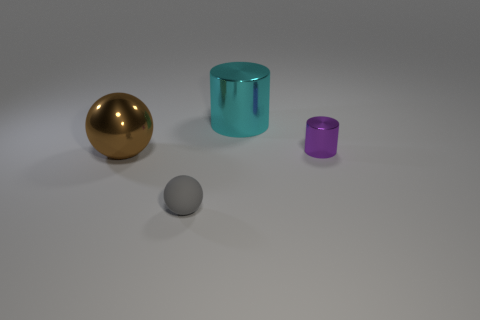Does the big object in front of the large cylinder have the same shape as the cyan object?
Provide a succinct answer. No. There is a small object behind the tiny object that is in front of the metal thing that is to the left of the small matte object; what shape is it?
Your answer should be compact. Cylinder. What is the thing that is on the right side of the brown object and in front of the tiny metallic cylinder made of?
Your answer should be very brief. Rubber. Are there fewer small brown matte cylinders than cylinders?
Make the answer very short. Yes. Do the tiny shiny object and the large shiny object that is to the left of the tiny sphere have the same shape?
Keep it short and to the point. No. There is a metallic cylinder on the left side of the purple cylinder; is its size the same as the big brown ball?
Provide a succinct answer. Yes. There is a shiny thing that is the same size as the gray rubber thing; what is its shape?
Provide a short and direct response. Cylinder. Does the gray thing have the same shape as the purple thing?
Make the answer very short. No. What number of gray rubber objects are the same shape as the brown shiny object?
Keep it short and to the point. 1. There is a small gray matte thing; how many gray rubber things are behind it?
Offer a very short reply. 0. 